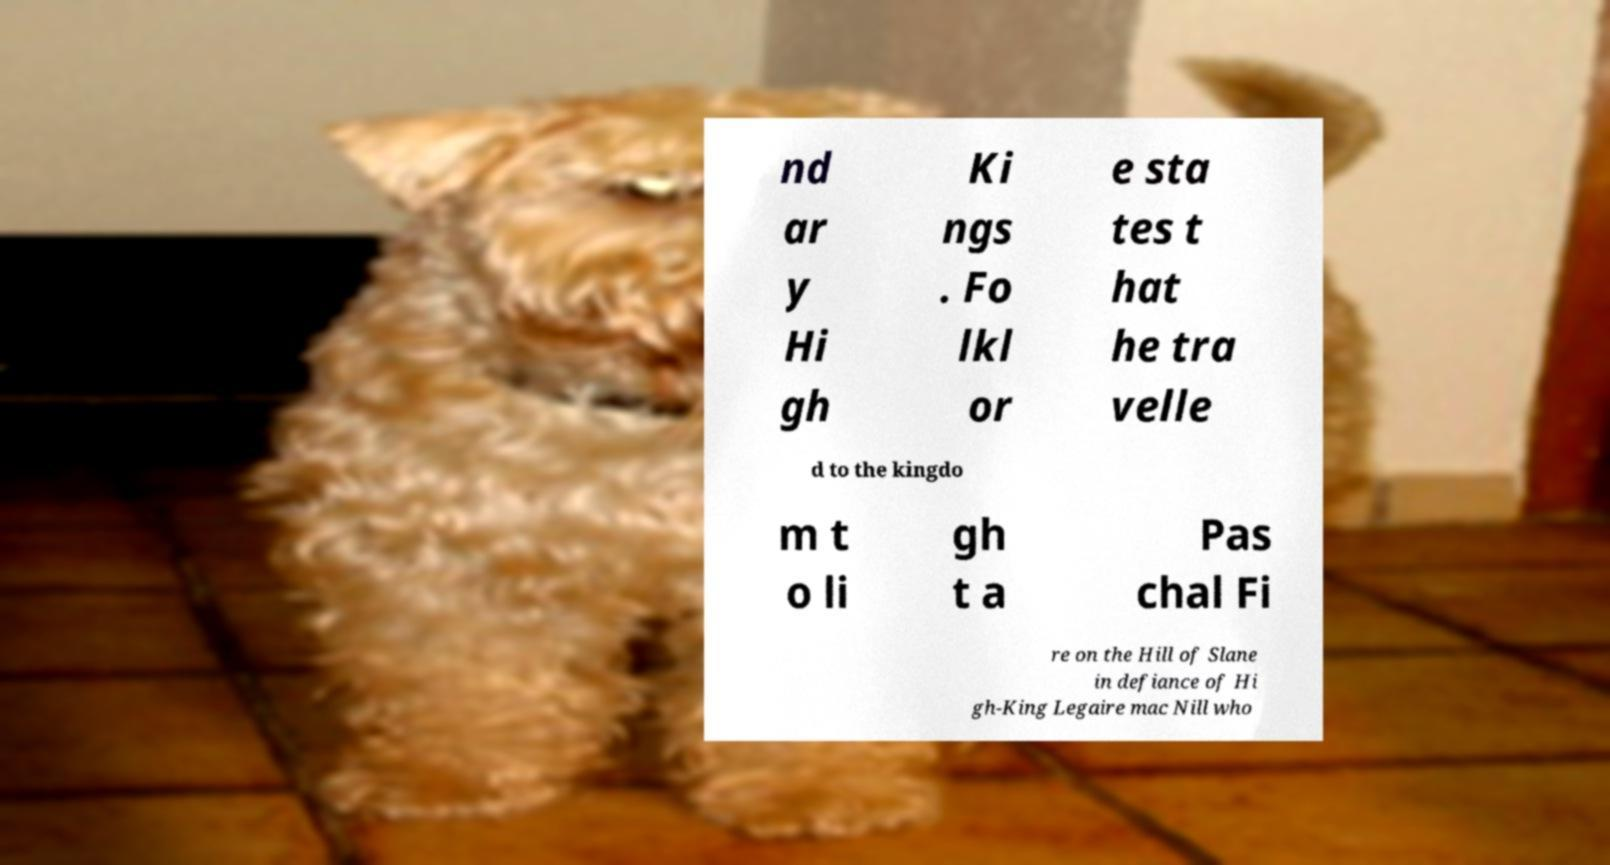Please identify and transcribe the text found in this image. nd ar y Hi gh Ki ngs . Fo lkl or e sta tes t hat he tra velle d to the kingdo m t o li gh t a Pas chal Fi re on the Hill of Slane in defiance of Hi gh-King Legaire mac Nill who 